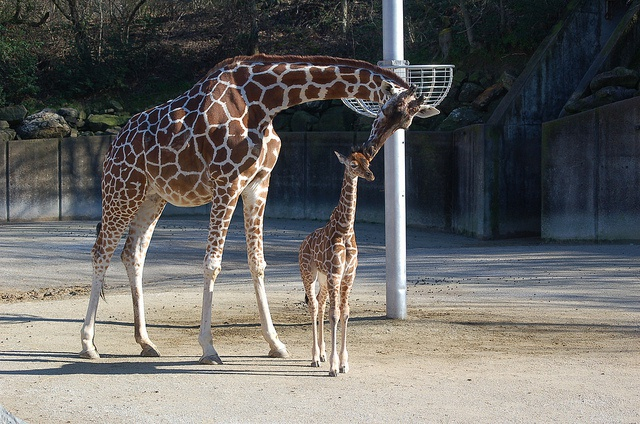Describe the objects in this image and their specific colors. I can see giraffe in gray, black, darkgray, and maroon tones and giraffe in gray, ivory, and maroon tones in this image. 